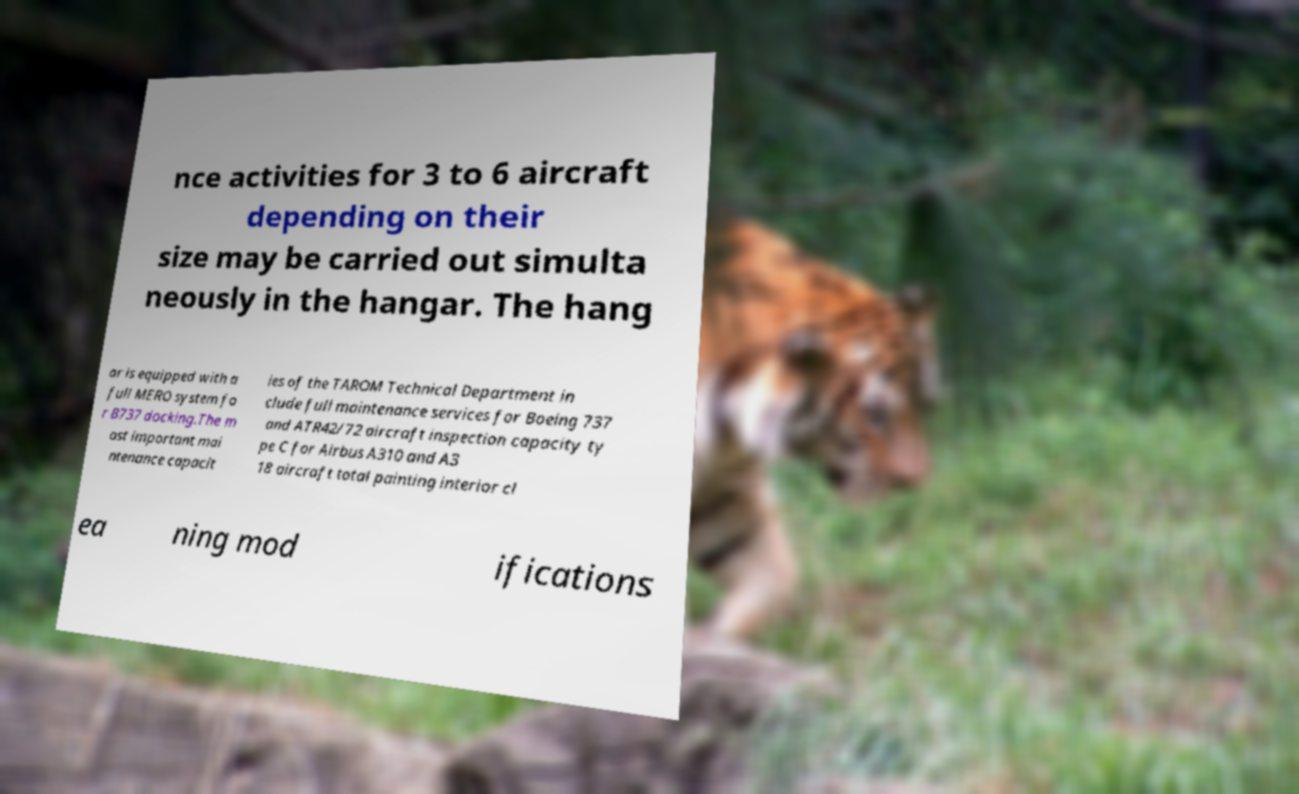Could you extract and type out the text from this image? nce activities for 3 to 6 aircraft depending on their size may be carried out simulta neously in the hangar. The hang ar is equipped with a full MERO system fo r B737 docking.The m ost important mai ntenance capacit ies of the TAROM Technical Department in clude full maintenance services for Boeing 737 and ATR42/72 aircraft inspection capacity ty pe C for Airbus A310 and A3 18 aircraft total painting interior cl ea ning mod ifications 